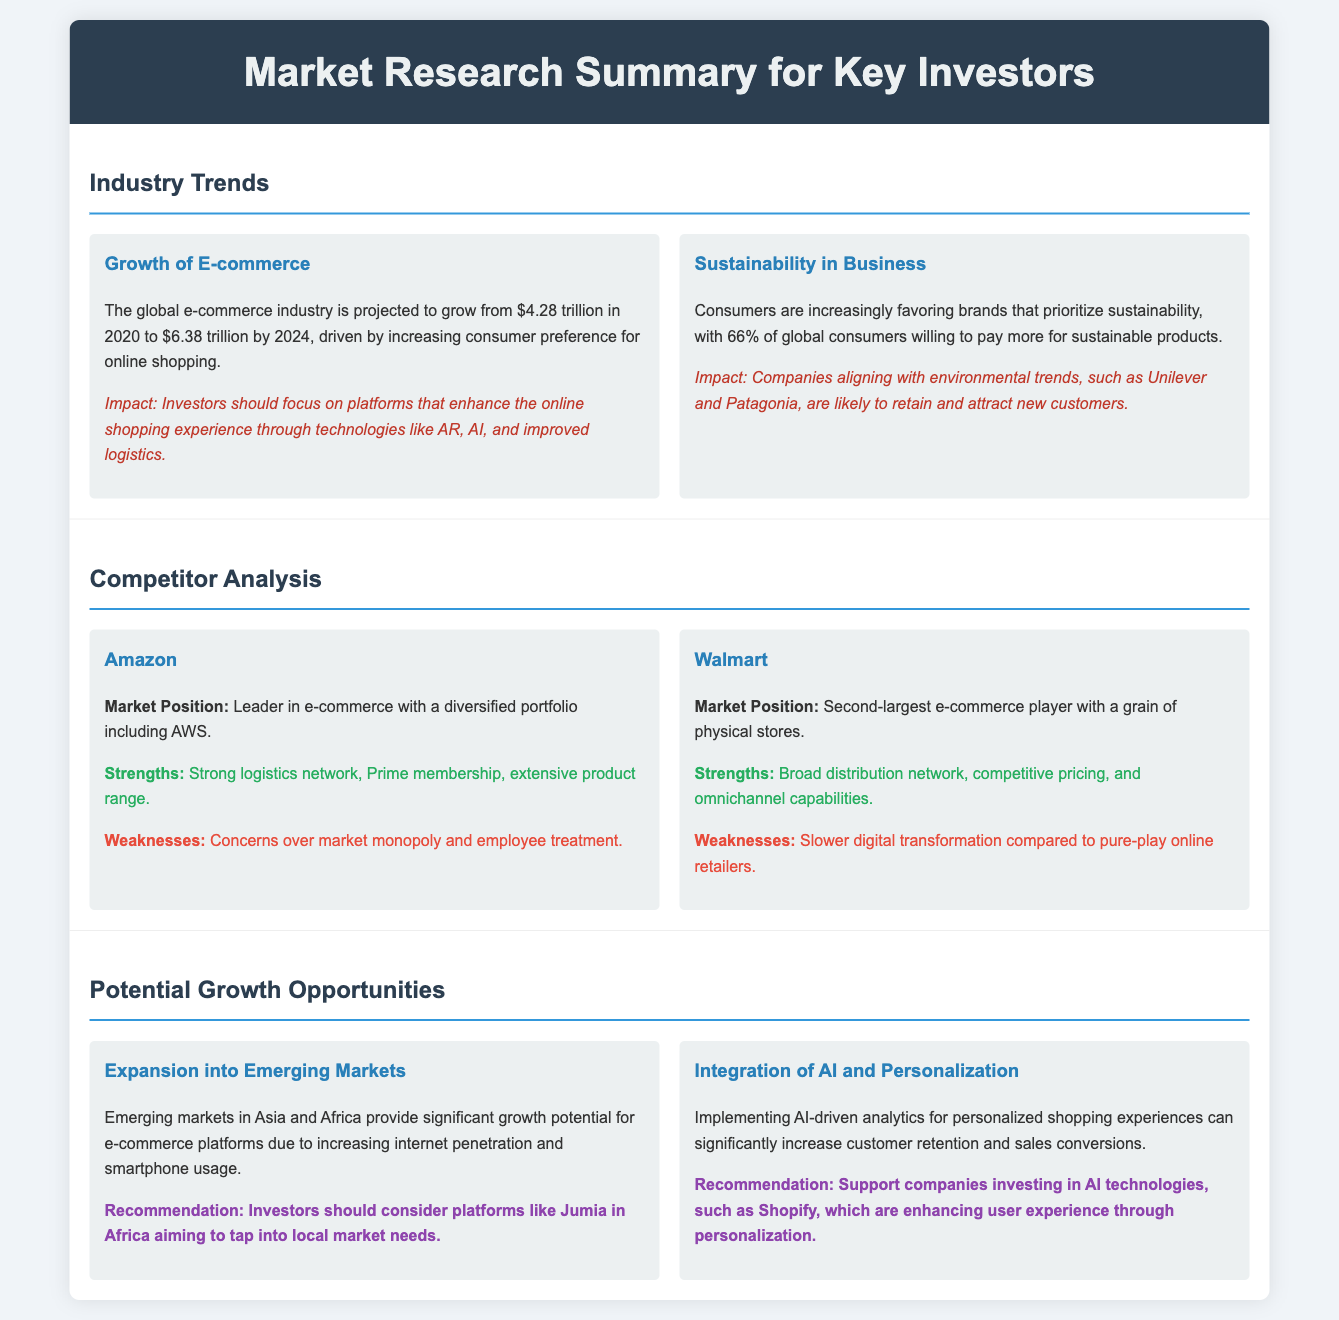What is the projected value of the global e-commerce industry in 2024? The document states that the global e-commerce industry is projected to grow to $6.38 trillion by 2024.
Answer: $6.38 trillion What percentage of consumers are willing to pay more for sustainable products? The document mentions that 66% of global consumers are willing to pay more for sustainable products.
Answer: 66% Who is the market leader in e-commerce? According to the document, Amazon is identified as the leader in e-commerce.
Answer: Amazon What is a key strength of Walmart? The strengths listed in the document for Walmart include its broad distribution network.
Answer: Broad distribution network What growth potential exists in Asia and Africa? The document points out that emerging markets in Asia and Africa provide significant growth potential for e-commerce platforms.
Answer: Significant growth potential Which technology is recommended for enhancing user experience? The document suggests integrating AI-driven analytics for personalized shopping experiences to enhance user experience.
Answer: AI-driven analytics What company does the document recommend for investment due to its focus on AI technologies? The recommendation in the document is to support companies like Shopify for their investment in AI technologies.
Answer: Shopify What concern is noted regarding Amazon's market presence? The document highlights concerns over Amazon's market monopoly as a noted weakness.
Answer: Market monopoly 